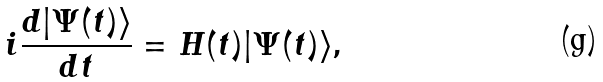<formula> <loc_0><loc_0><loc_500><loc_500>i \frac { d | \Psi ( t ) \rangle } { d t } = H ( t ) | \Psi ( t ) \rangle ,</formula> 